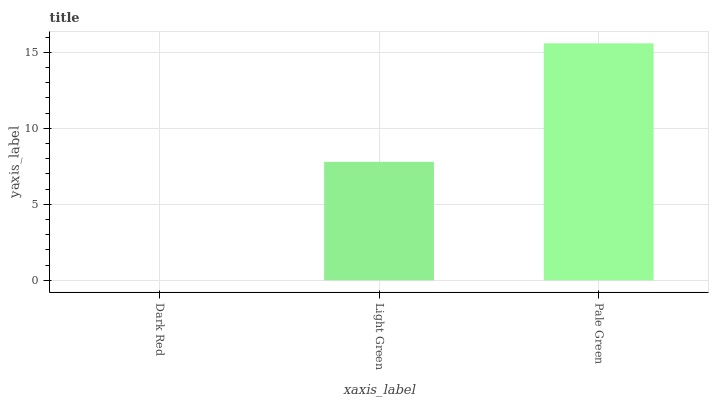Is Light Green the minimum?
Answer yes or no. No. Is Light Green the maximum?
Answer yes or no. No. Is Light Green greater than Dark Red?
Answer yes or no. Yes. Is Dark Red less than Light Green?
Answer yes or no. Yes. Is Dark Red greater than Light Green?
Answer yes or no. No. Is Light Green less than Dark Red?
Answer yes or no. No. Is Light Green the high median?
Answer yes or no. Yes. Is Light Green the low median?
Answer yes or no. Yes. Is Dark Red the high median?
Answer yes or no. No. Is Pale Green the low median?
Answer yes or no. No. 